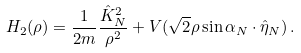<formula> <loc_0><loc_0><loc_500><loc_500>H _ { 2 } ( \rho ) = \frac { 1 } { 2 m } \frac { \hat { K } _ { N } ^ { 2 } } { \rho ^ { 2 } } + V ( \sqrt { 2 } \rho \sin \alpha _ { N } \cdot \hat { \eta } _ { N } ) \, .</formula> 